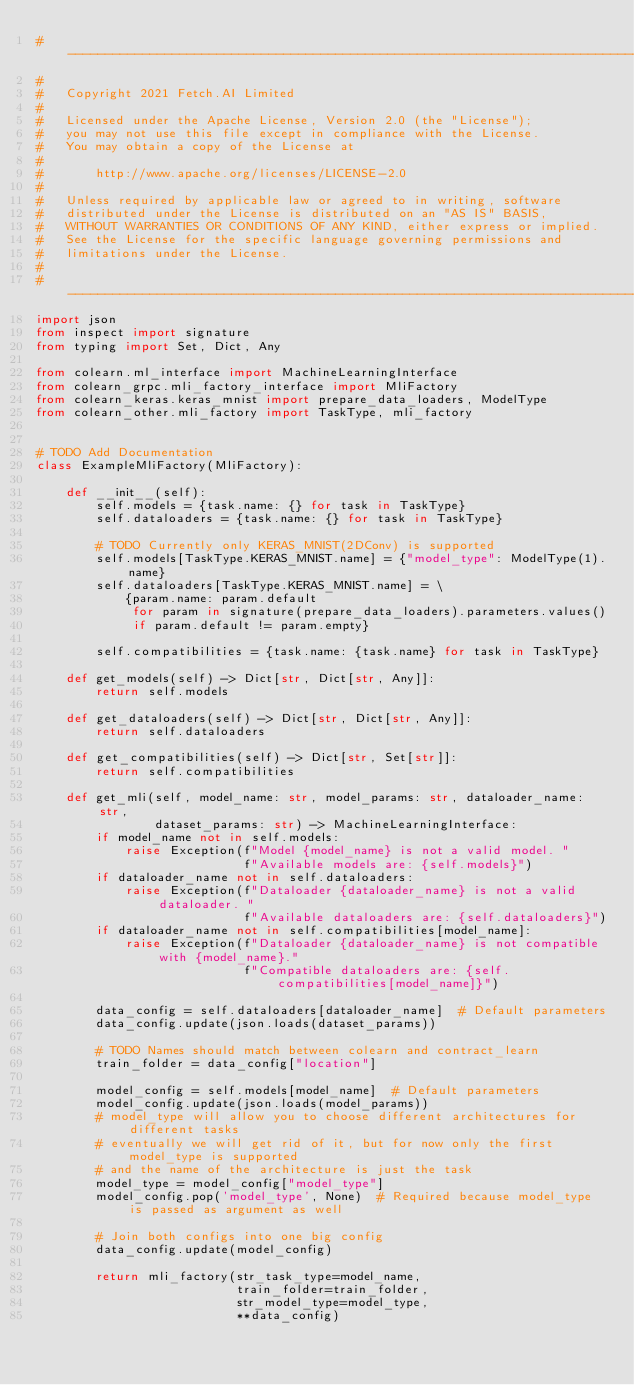Convert code to text. <code><loc_0><loc_0><loc_500><loc_500><_Python_># ------------------------------------------------------------------------------
#
#   Copyright 2021 Fetch.AI Limited
#
#   Licensed under the Apache License, Version 2.0 (the "License");
#   you may not use this file except in compliance with the License.
#   You may obtain a copy of the License at
#
#       http://www.apache.org/licenses/LICENSE-2.0
#
#   Unless required by applicable law or agreed to in writing, software
#   distributed under the License is distributed on an "AS IS" BASIS,
#   WITHOUT WARRANTIES OR CONDITIONS OF ANY KIND, either express or implied.
#   See the License for the specific language governing permissions and
#   limitations under the License.
#
# ------------------------------------------------------------------------------
import json
from inspect import signature
from typing import Set, Dict, Any

from colearn.ml_interface import MachineLearningInterface
from colearn_grpc.mli_factory_interface import MliFactory
from colearn_keras.keras_mnist import prepare_data_loaders, ModelType
from colearn_other.mli_factory import TaskType, mli_factory


# TODO Add Documentation
class ExampleMliFactory(MliFactory):

    def __init__(self):
        self.models = {task.name: {} for task in TaskType}
        self.dataloaders = {task.name: {} for task in TaskType}

        # TODO Currently only KERAS_MNIST(2DConv) is supported
        self.models[TaskType.KERAS_MNIST.name] = {"model_type": ModelType(1).name}
        self.dataloaders[TaskType.KERAS_MNIST.name] = \
            {param.name: param.default
             for param in signature(prepare_data_loaders).parameters.values()
             if param.default != param.empty}

        self.compatibilities = {task.name: {task.name} for task in TaskType}

    def get_models(self) -> Dict[str, Dict[str, Any]]:
        return self.models

    def get_dataloaders(self) -> Dict[str, Dict[str, Any]]:
        return self.dataloaders

    def get_compatibilities(self) -> Dict[str, Set[str]]:
        return self.compatibilities

    def get_mli(self, model_name: str, model_params: str, dataloader_name: str,
                dataset_params: str) -> MachineLearningInterface:
        if model_name not in self.models:
            raise Exception(f"Model {model_name} is not a valid model. "
                            f"Available models are: {self.models}")
        if dataloader_name not in self.dataloaders:
            raise Exception(f"Dataloader {dataloader_name} is not a valid dataloader. "
                            f"Available dataloaders are: {self.dataloaders}")
        if dataloader_name not in self.compatibilities[model_name]:
            raise Exception(f"Dataloader {dataloader_name} is not compatible with {model_name}."
                            f"Compatible dataloaders are: {self.compatibilities[model_name]}")

        data_config = self.dataloaders[dataloader_name]  # Default parameters
        data_config.update(json.loads(dataset_params))

        # TODO Names should match between colearn and contract_learn
        train_folder = data_config["location"]

        model_config = self.models[model_name]  # Default parameters
        model_config.update(json.loads(model_params))
        # model_type will allow you to choose different architectures for different tasks
        # eventually we will get rid of it, but for now only the first model_type is supported
        # and the name of the architecture is just the task
        model_type = model_config["model_type"]
        model_config.pop('model_type', None)  # Required because model_type is passed as argument as well

        # Join both configs into one big config
        data_config.update(model_config)

        return mli_factory(str_task_type=model_name,
                           train_folder=train_folder,
                           str_model_type=model_type,
                           **data_config)
</code> 